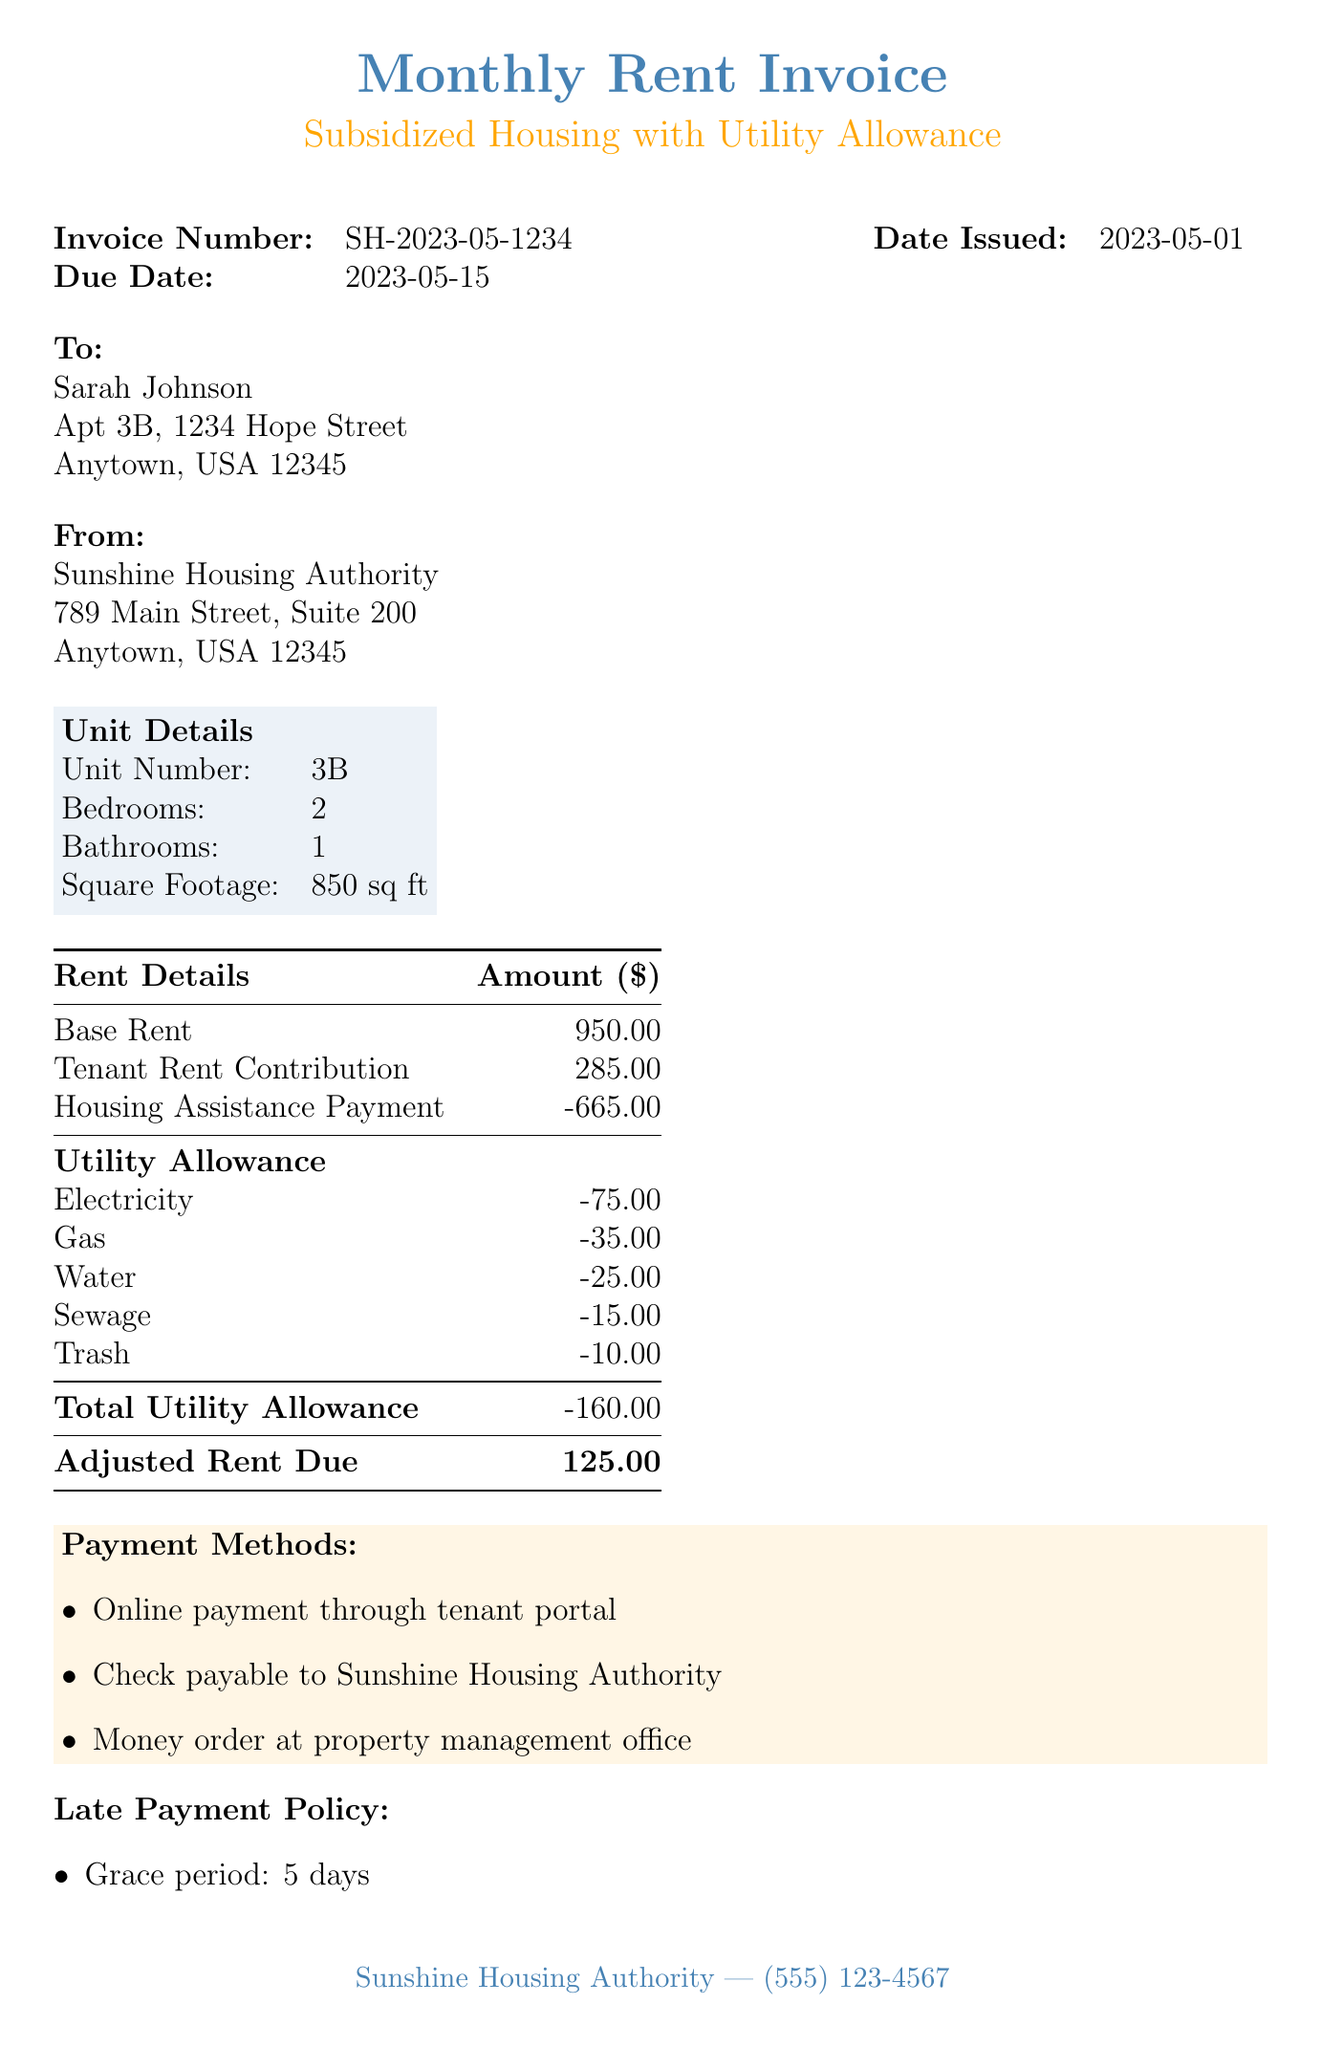What is the invoice number? The invoice number is a unique identifier for the document, which is specified near the top.
Answer: SH-2023-05-1234 What is the total utility allowance? The total utility allowance is provided in the rent details section and sums up the individual utility allowances.
Answer: 160 What is the due date for the rent? The due date is the date by which the rent must be paid, specified in the document.
Answer: 2023-05-15 What is the tenant's rent contribution? The tenant's rent contribution is listed under the rent details section as the portion the tenant is responsible for.
Answer: 285 What payment methods are available? The payment methods section lists ways in which the tenant can pay their rent.
Answer: Online payment through tenant portal, Check payable to Sunshine Housing Authority, Money order at property management office How much is the adjusted rent due? The adjusted rent due is the amount the tenant needs to pay after considering any assistance and utility allowances.
Answer: 125 What is included in the utility allowance? The utility allowance outlines specific allowances for different utilities that contribute to the total utility amount deducted from the rent.
Answer: Electricity, Gas, Water, Sewage, Trash When should the tenant recertify their income? The recertification deadline is an important note that indicates when the tenant must report their income.
Answer: July 1st Is there a late fee for the rent? The late payment policy section specifies penalties for late payments of rent.
Answer: 25 